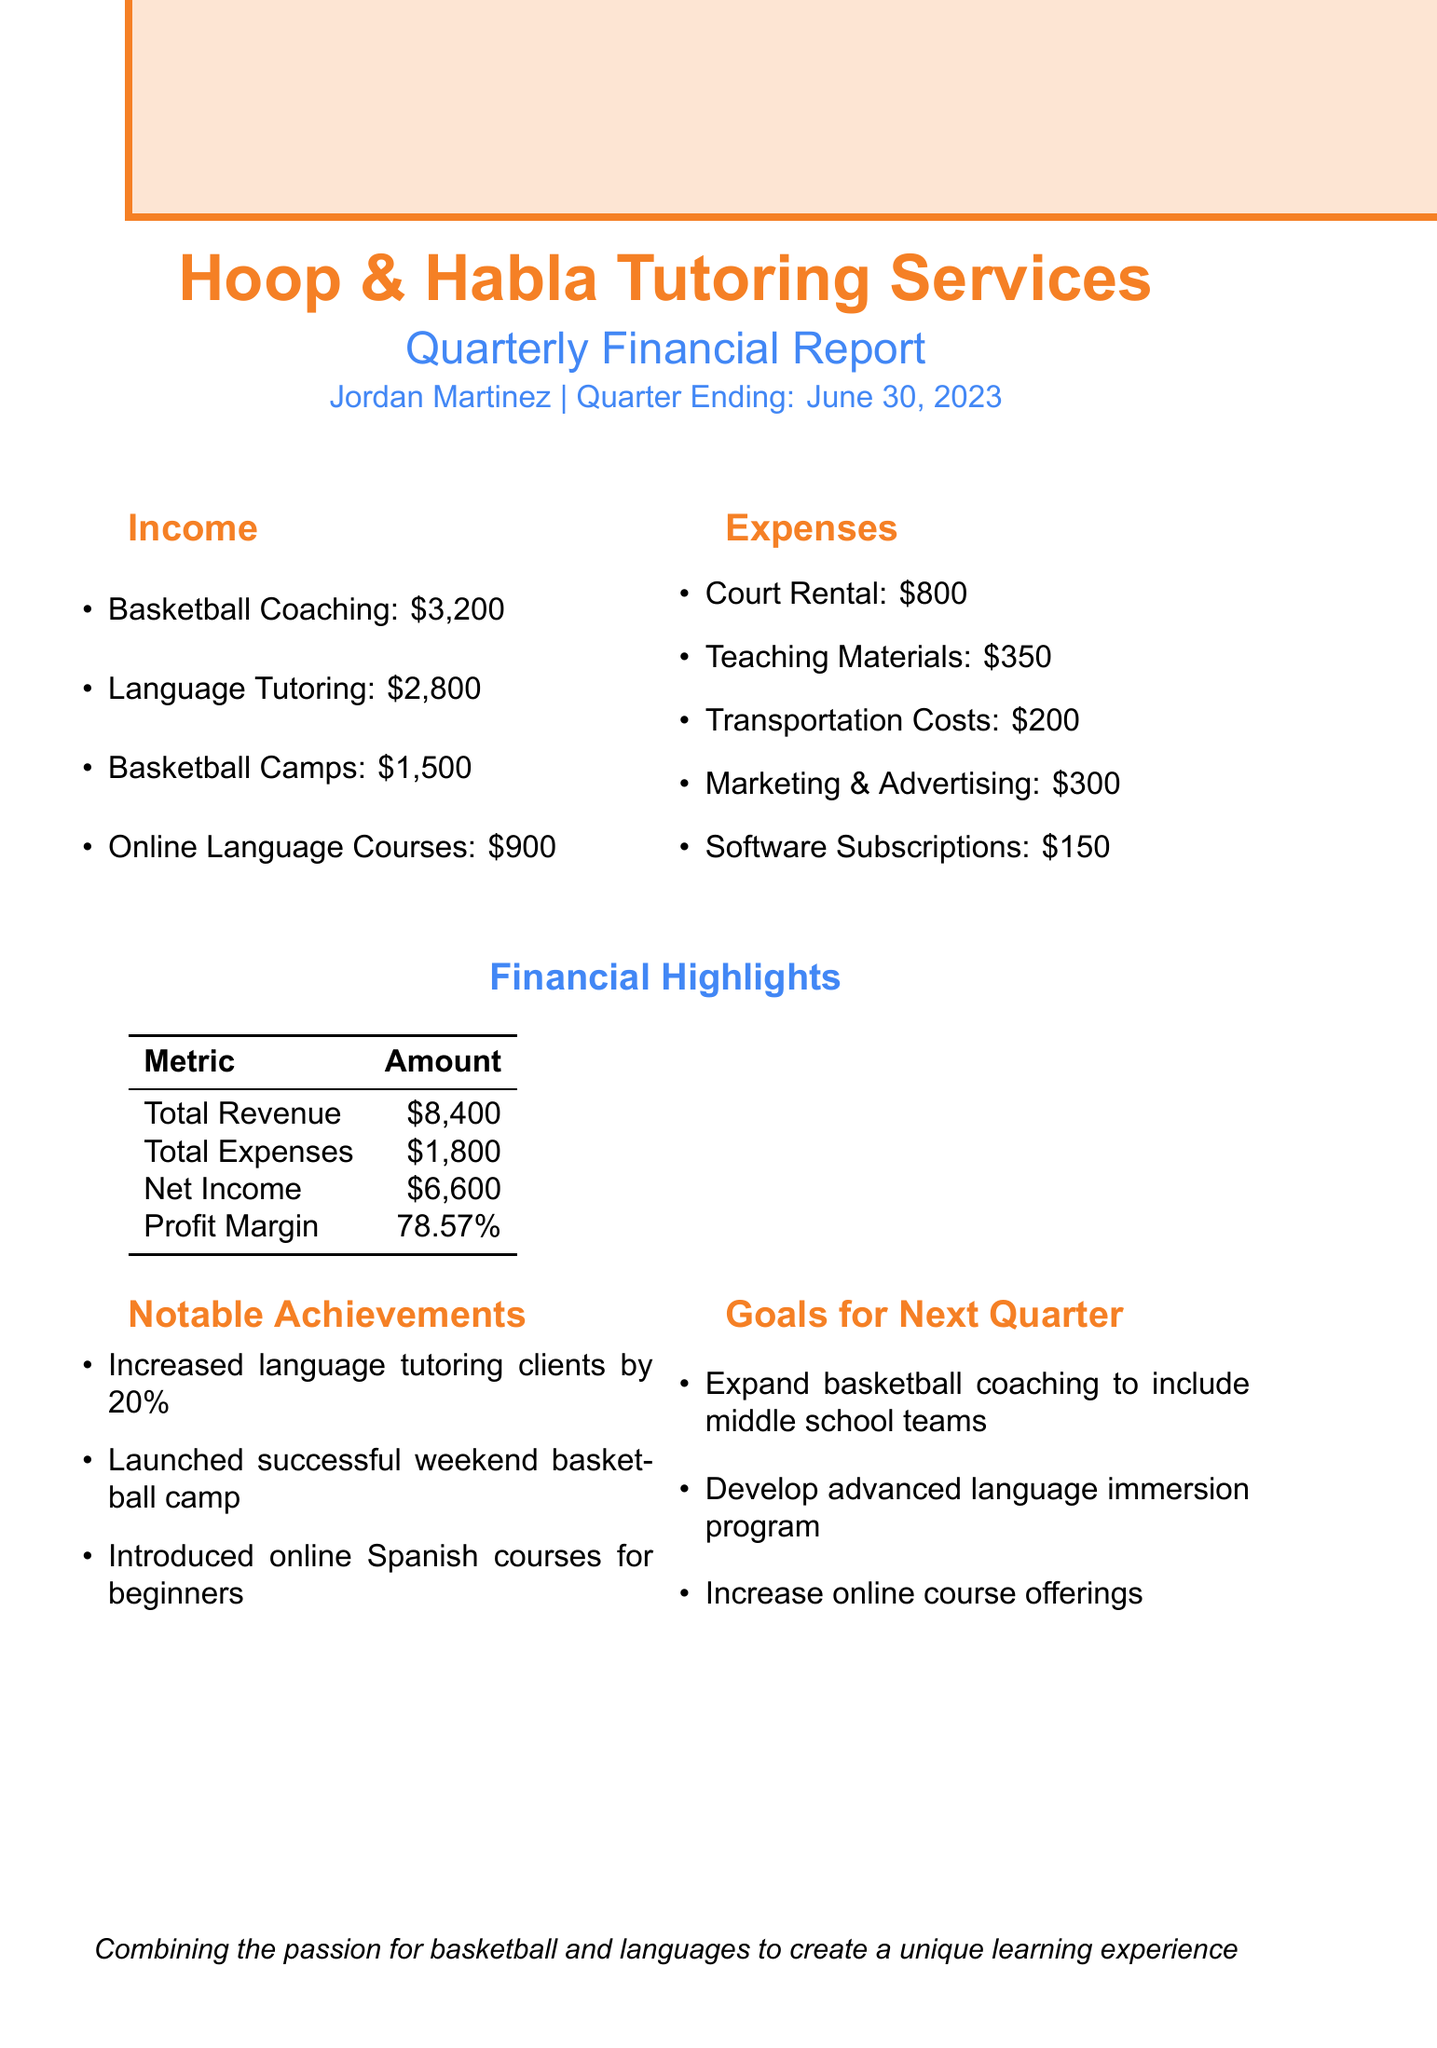what is the name of the business? The name of the business is provided in the document's header.
Answer: Hoop & Habla Tutoring Services who is the owner of the business? The document states the owner's name at the top section of the report.
Answer: Jordan Martinez what is the total revenue? The total revenue is calculated by summing all income sources listed in the document.
Answer: $8,400 what is the net income? The net income is the total revenue minus total expenses as shown in the financial highlights.
Answer: $6,600 how much was spent on court rental? The document lists individual expenses, including the amount spent on court rental.
Answer: $800 what percentage of profit margin is reported? The profit margin is provided as part of the financial highlights in the document.
Answer: 78.57% how much did language tutoring contribute to the total income? The income from language tutoring is specified as part of the overall income breakdown in the document.
Answer: $2,800 what notable achievement involved language tutoring? The document includes notable achievements related to language tutoring, particularly the increase in clients.
Answer: Increased language tutoring clients by 20% what is one goal for the next quarter? The document lists several goals for the next quarter, showing the future plans of the business.
Answer: Expand basketball coaching to include middle school teams 